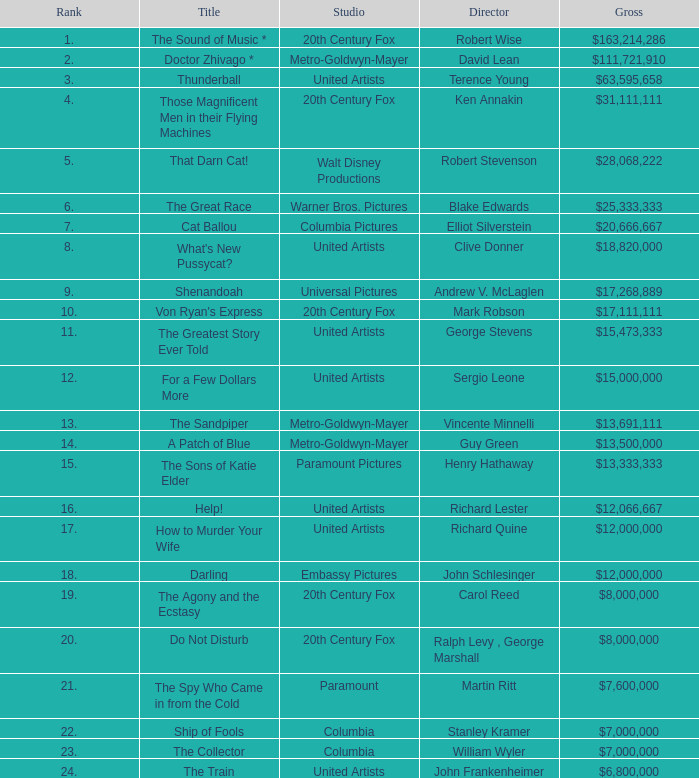What is Studio, when Title is "Do Not Disturb"? 20th Century Fox. 